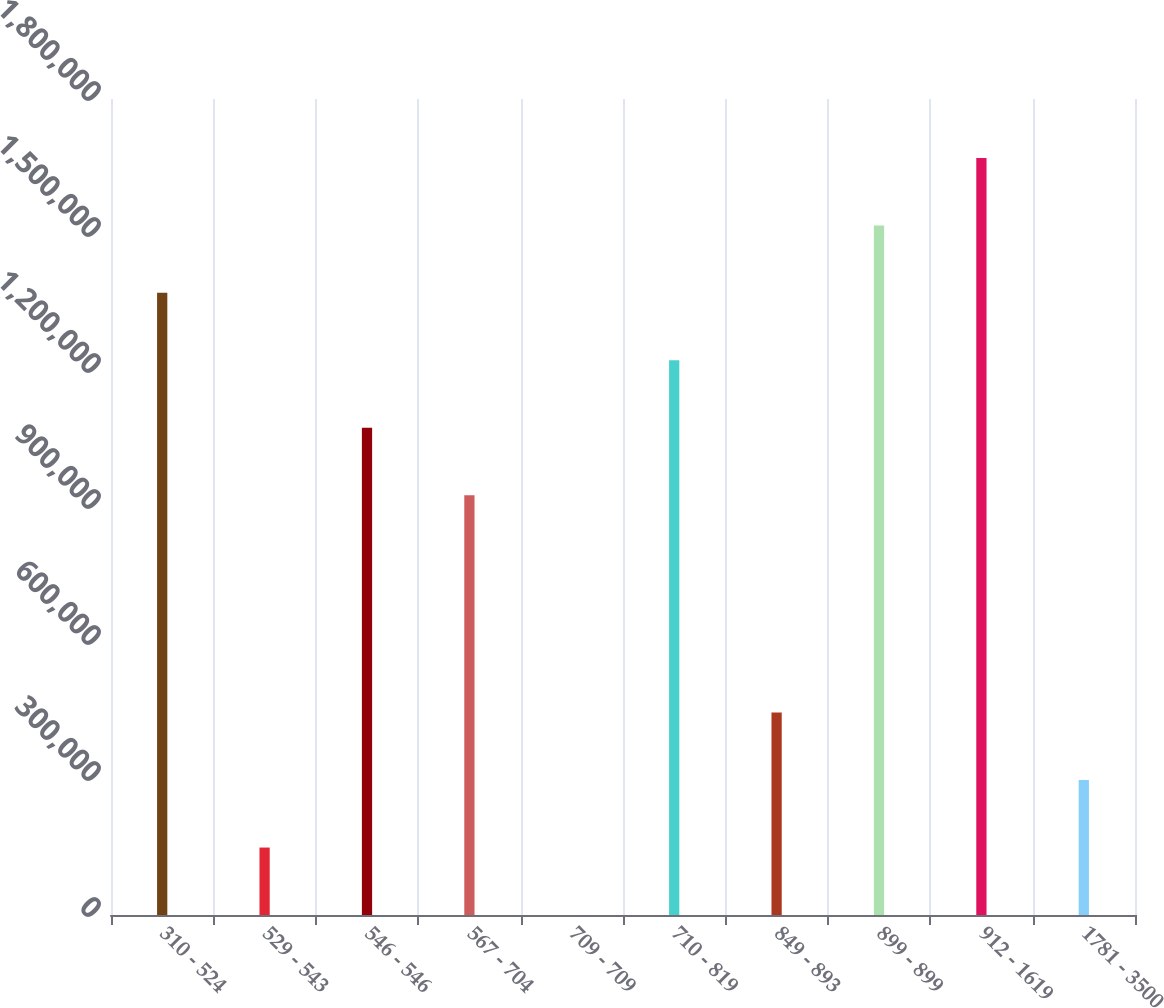Convert chart. <chart><loc_0><loc_0><loc_500><loc_500><bar_chart><fcel>310 - 524<fcel>529 - 543<fcel>546 - 546<fcel>567 - 704<fcel>709 - 709<fcel>710 - 819<fcel>849 - 893<fcel>899 - 899<fcel>912 - 1619<fcel>1781 - 3500<nl><fcel>1.3724e+06<fcel>148813<fcel>1.07478e+06<fcel>925966<fcel>0.54<fcel>1.22359e+06<fcel>446437<fcel>1.52121e+06<fcel>1.67003e+06<fcel>297625<nl></chart> 